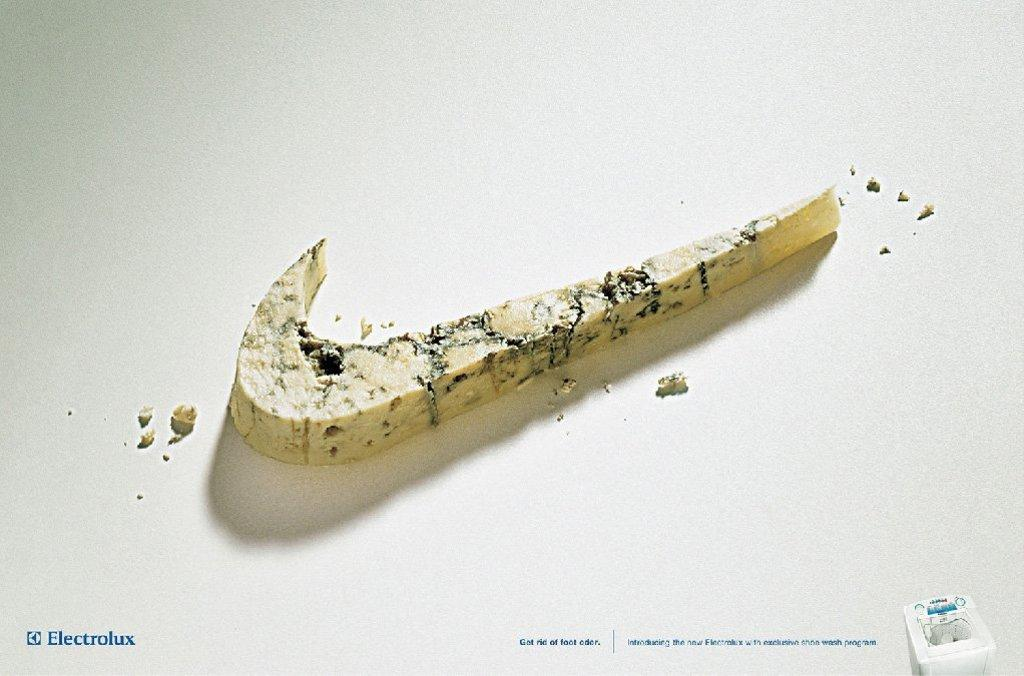What is the main feature of the image? The image contains a logo. What does the logo seem to represent? The logo appears to represent food. Are there any additional elements visible in the image besides the logo? Yes, there are watermarks visible in the image. What is the color of the background in the image? The background of the image is white in color. Can you see the sky in the image? No, the sky is not visible in the image; the background is white. What type of spoon is used to burst the watermarks in the image? There are no spoons or bursting actions present in the image. 